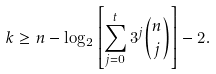Convert formula to latex. <formula><loc_0><loc_0><loc_500><loc_500>k \geq n - \log _ { 2 } \left [ \sum _ { j = 0 } ^ { t } 3 ^ { j } \binom { n } { j } \right ] - 2 .</formula> 